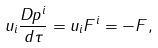Convert formula to latex. <formula><loc_0><loc_0><loc_500><loc_500>u _ { i } \frac { D p ^ { i } } { d \tau } = u _ { i } F ^ { i } = - F ,</formula> 